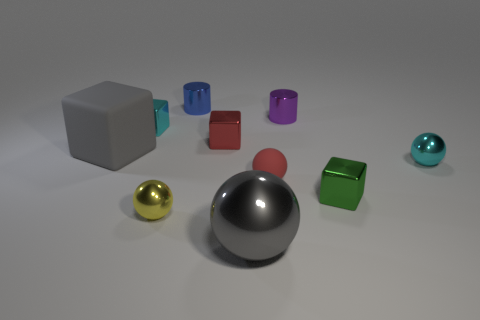Subtract all small metallic blocks. How many blocks are left? 1 Subtract 1 cylinders. How many cylinders are left? 1 Subtract all red blocks. How many blocks are left? 3 Subtract 1 gray balls. How many objects are left? 9 Subtract all cubes. How many objects are left? 6 Subtract all brown balls. Subtract all red cylinders. How many balls are left? 4 Subtract all small yellow metallic balls. Subtract all purple shiny things. How many objects are left? 8 Add 7 metallic blocks. How many metallic blocks are left? 10 Add 2 gray blocks. How many gray blocks exist? 3 